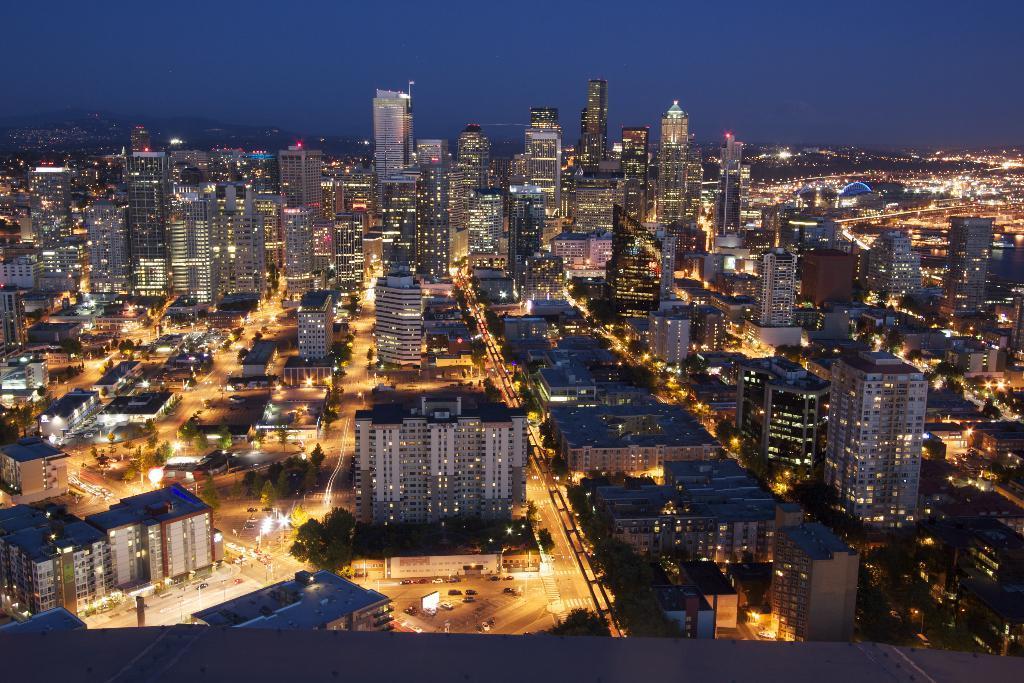Can you describe this image briefly? In this picture I can see buildings, trees, vehicles, lights, and in the background there is sky. 